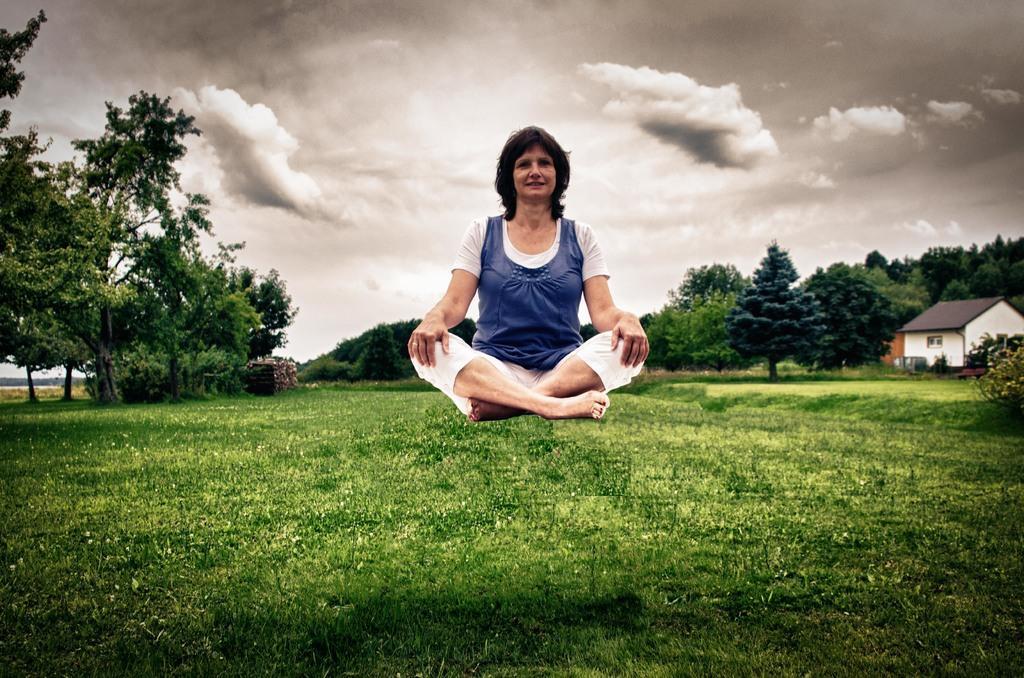How would you summarize this image in a sentence or two? In this picture we can see a woman is sitting on the ground, at the bottom there is grass, on the right side we can see a house, in the background there are some trees, we can see the sky and clouds at the top of the picture. 